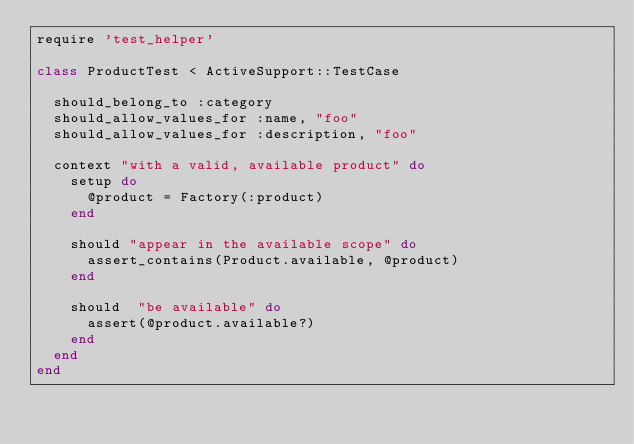Convert code to text. <code><loc_0><loc_0><loc_500><loc_500><_Ruby_>require 'test_helper'

class ProductTest < ActiveSupport::TestCase
  
  should_belong_to :category
  should_allow_values_for :name, "foo"
  should_allow_values_for :description, "foo"
  
  context "with a valid, available product" do 
    setup do 
      @product = Factory(:product)      
    end
    
    should "appear in the available scope" do      
      assert_contains(Product.available, @product)
    end
    
    should  "be available" do
      assert(@product.available?)
    end
  end
end
</code> 